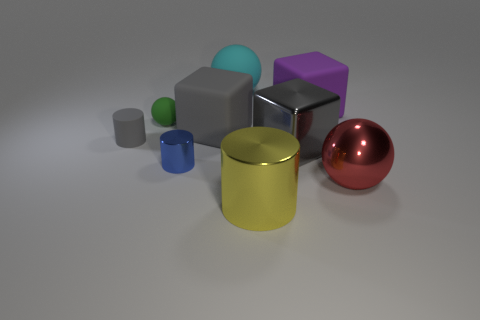Is there a large matte block that has the same color as the matte cylinder?
Ensure brevity in your answer.  Yes. What is the size of the metallic ball?
Provide a short and direct response. Large. Is the color of the tiny ball the same as the rubber cylinder?
Give a very brief answer. No. How many things are large yellow metallic cylinders or gray things in front of the big gray rubber block?
Provide a succinct answer. 3. What number of green rubber spheres are to the right of the rubber ball on the right side of the large rubber block that is in front of the green rubber object?
Your response must be concise. 0. What number of tiny gray things are there?
Your response must be concise. 1. Does the object in front of the red object have the same size as the purple cube?
Offer a terse response. Yes. What number of rubber things are blue cylinders or small purple spheres?
Make the answer very short. 0. How many metal blocks are behind the large matte block that is in front of the green object?
Your answer should be very brief. 0. What shape is the large object that is both behind the green matte sphere and to the left of the purple matte object?
Your answer should be very brief. Sphere. 